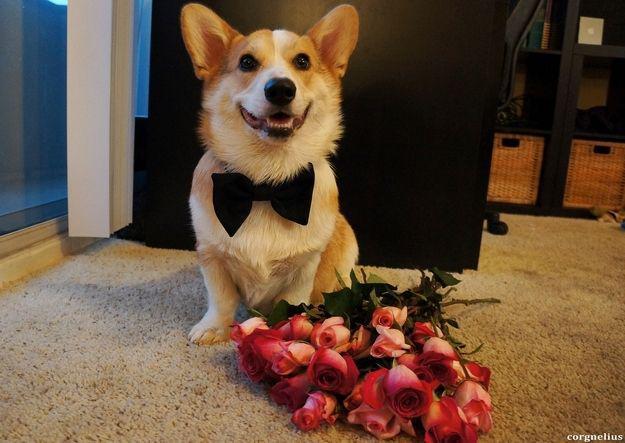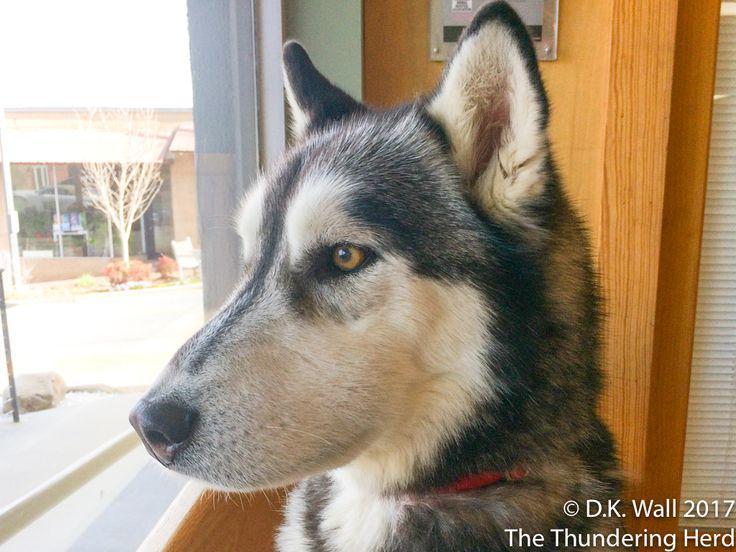The first image is the image on the left, the second image is the image on the right. Evaluate the accuracy of this statement regarding the images: "Two dogs are sitting.". Is it true? Answer yes or no. Yes. 